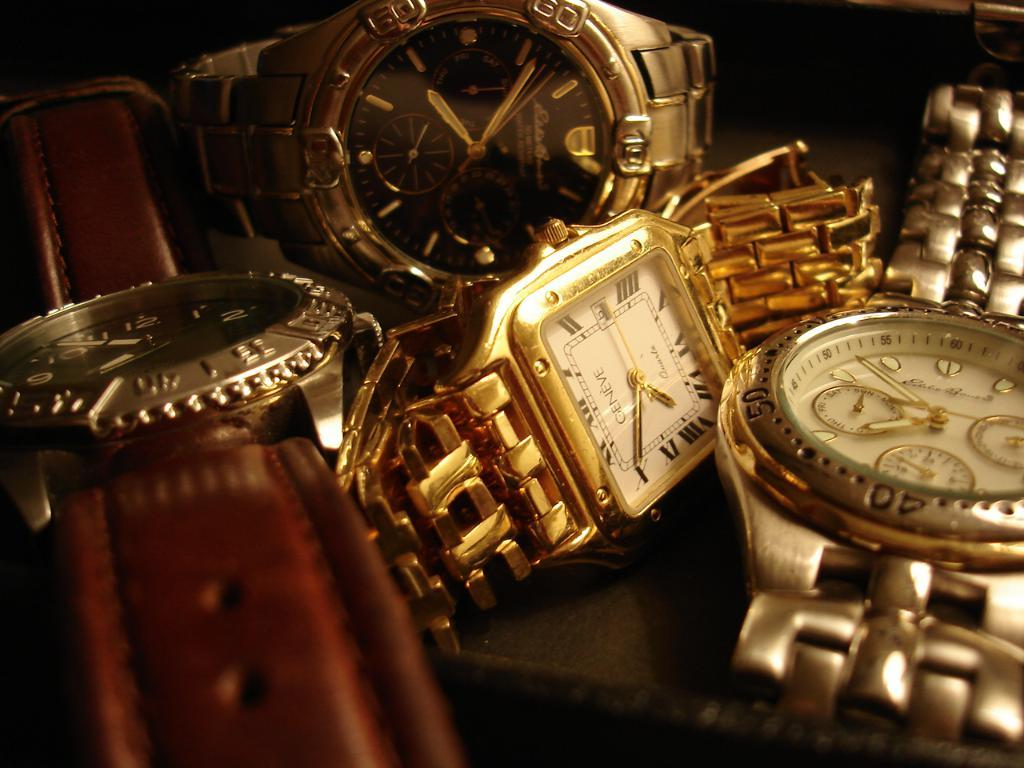<image>
Share a concise interpretation of the image provided. Multiple wrist watches including a one from GENEVE. 